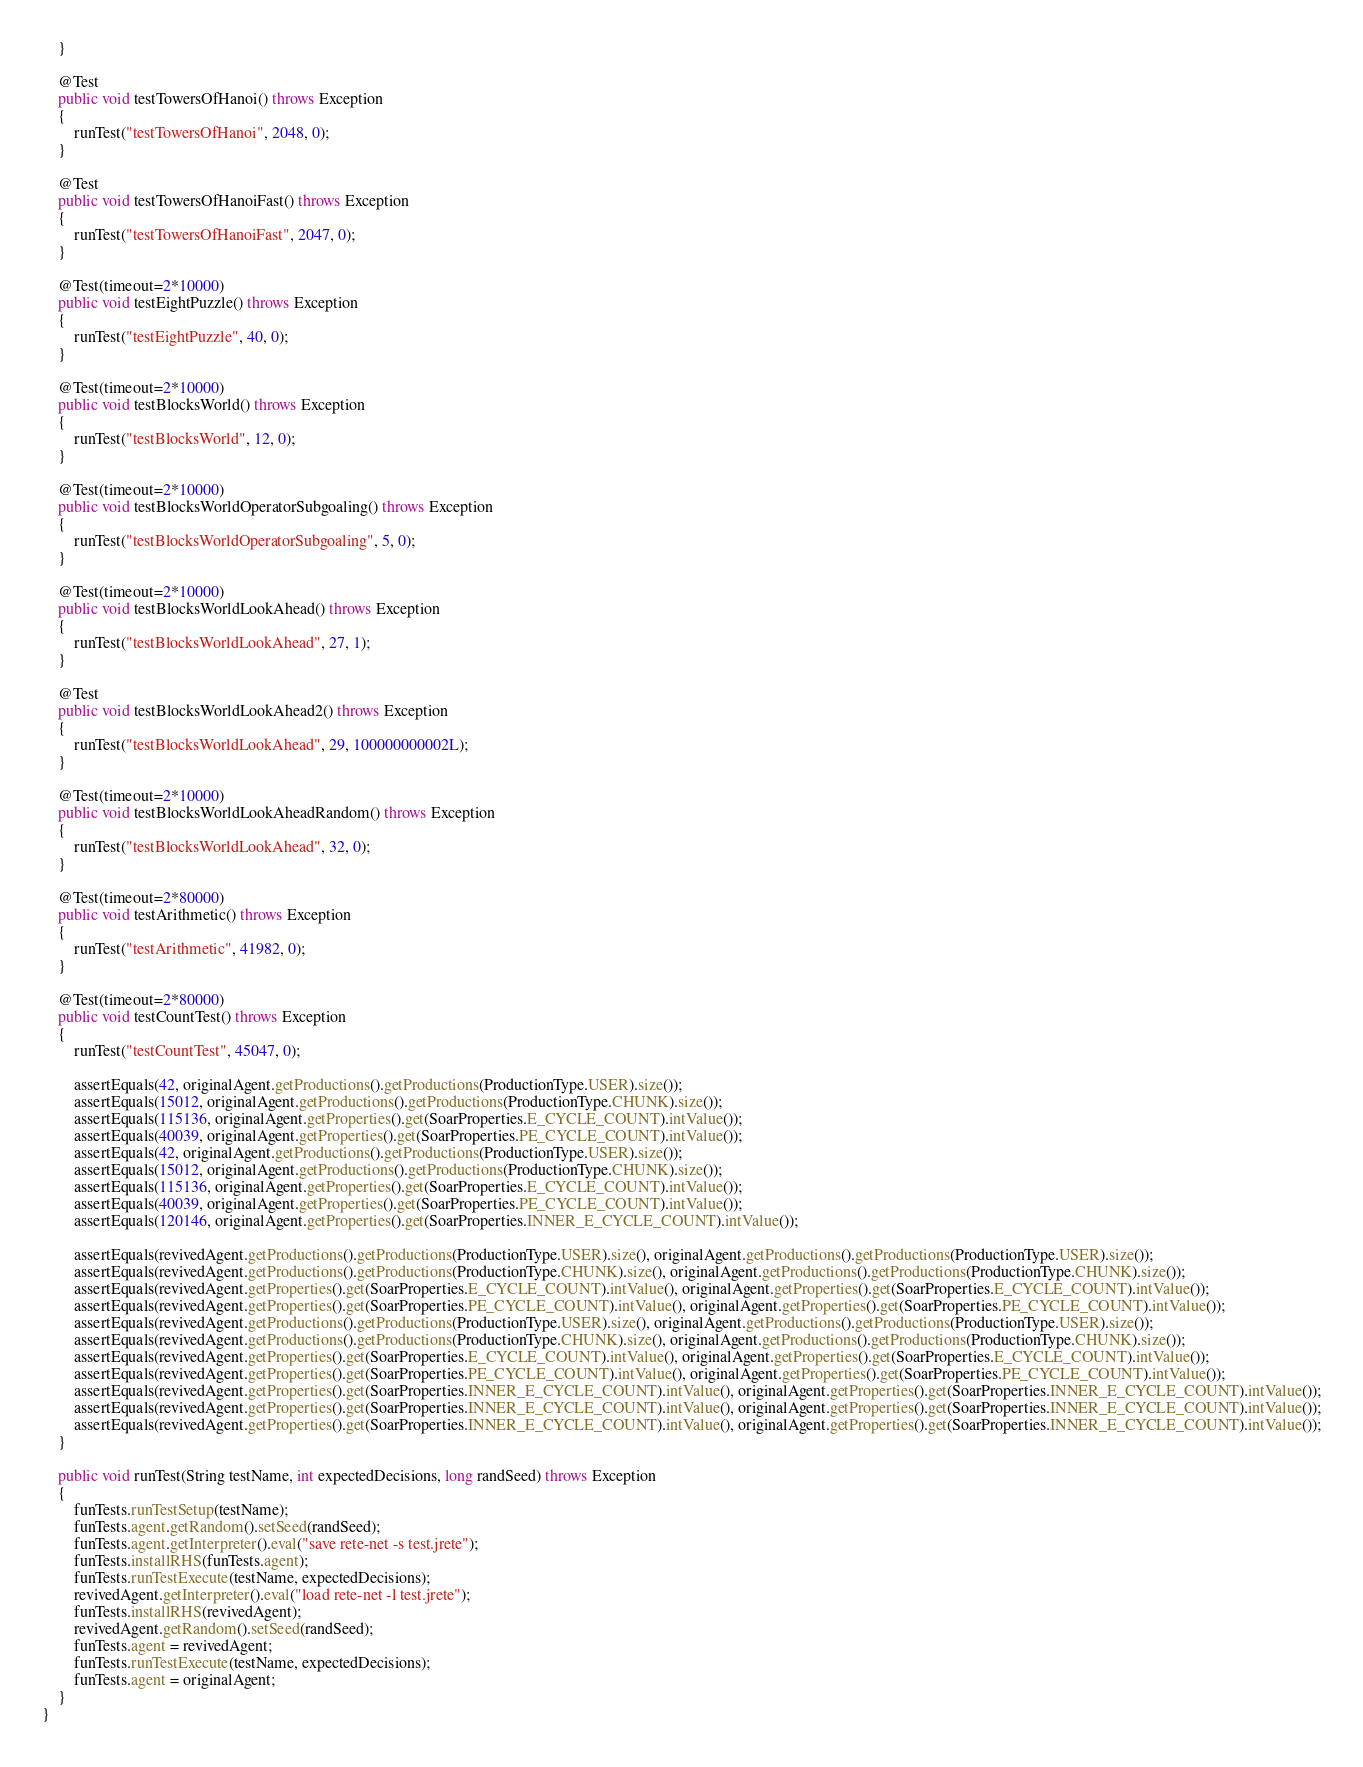<code> <loc_0><loc_0><loc_500><loc_500><_Java_>    }
    
    @Test
    public void testTowersOfHanoi() throws Exception
    {
        runTest("testTowersOfHanoi", 2048, 0);
    }
    
    @Test
    public void testTowersOfHanoiFast() throws Exception
    {
        runTest("testTowersOfHanoiFast", 2047, 0);
    }
    
    @Test(timeout=2*10000)
    public void testEightPuzzle() throws Exception
    {
        runTest("testEightPuzzle", 40, 0);
    }
    
    @Test(timeout=2*10000)
    public void testBlocksWorld() throws Exception
    {
        runTest("testBlocksWorld", 12, 0);
    }
 
    @Test(timeout=2*10000)
    public void testBlocksWorldOperatorSubgoaling() throws Exception
    {
        runTest("testBlocksWorldOperatorSubgoaling", 5, 0);
    }
    
    @Test(timeout=2*10000)
    public void testBlocksWorldLookAhead() throws Exception
    {
        runTest("testBlocksWorldLookAhead", 27, 1);
    }
    
    @Test
    public void testBlocksWorldLookAhead2() throws Exception
    {
        runTest("testBlocksWorldLookAhead", 29, 100000000002L);
    }
    
    @Test(timeout=2*10000)
    public void testBlocksWorldLookAheadRandom() throws Exception
    {
        runTest("testBlocksWorldLookAhead", 32, 0);
    }
    
    @Test(timeout=2*80000)
    public void testArithmetic() throws Exception
    {
        runTest("testArithmetic", 41982, 0);
    } 
    
    @Test(timeout=2*80000)
    public void testCountTest() throws Exception
    {
        runTest("testCountTest", 45047, 0);
        
        assertEquals(42, originalAgent.getProductions().getProductions(ProductionType.USER).size());
        assertEquals(15012, originalAgent.getProductions().getProductions(ProductionType.CHUNK).size());
        assertEquals(115136, originalAgent.getProperties().get(SoarProperties.E_CYCLE_COUNT).intValue());
        assertEquals(40039, originalAgent.getProperties().get(SoarProperties.PE_CYCLE_COUNT).intValue());
        assertEquals(42, originalAgent.getProductions().getProductions(ProductionType.USER).size());
        assertEquals(15012, originalAgent.getProductions().getProductions(ProductionType.CHUNK).size());
        assertEquals(115136, originalAgent.getProperties().get(SoarProperties.E_CYCLE_COUNT).intValue());
        assertEquals(40039, originalAgent.getProperties().get(SoarProperties.PE_CYCLE_COUNT).intValue());
        assertEquals(120146, originalAgent.getProperties().get(SoarProperties.INNER_E_CYCLE_COUNT).intValue());
        
        assertEquals(revivedAgent.getProductions().getProductions(ProductionType.USER).size(), originalAgent.getProductions().getProductions(ProductionType.USER).size());
        assertEquals(revivedAgent.getProductions().getProductions(ProductionType.CHUNK).size(), originalAgent.getProductions().getProductions(ProductionType.CHUNK).size());
        assertEquals(revivedAgent.getProperties().get(SoarProperties.E_CYCLE_COUNT).intValue(), originalAgent.getProperties().get(SoarProperties.E_CYCLE_COUNT).intValue());
        assertEquals(revivedAgent.getProperties().get(SoarProperties.PE_CYCLE_COUNT).intValue(), originalAgent.getProperties().get(SoarProperties.PE_CYCLE_COUNT).intValue());
        assertEquals(revivedAgent.getProductions().getProductions(ProductionType.USER).size(), originalAgent.getProductions().getProductions(ProductionType.USER).size());
        assertEquals(revivedAgent.getProductions().getProductions(ProductionType.CHUNK).size(), originalAgent.getProductions().getProductions(ProductionType.CHUNK).size());
        assertEquals(revivedAgent.getProperties().get(SoarProperties.E_CYCLE_COUNT).intValue(), originalAgent.getProperties().get(SoarProperties.E_CYCLE_COUNT).intValue());
        assertEquals(revivedAgent.getProperties().get(SoarProperties.PE_CYCLE_COUNT).intValue(), originalAgent.getProperties().get(SoarProperties.PE_CYCLE_COUNT).intValue());
        assertEquals(revivedAgent.getProperties().get(SoarProperties.INNER_E_CYCLE_COUNT).intValue(), originalAgent.getProperties().get(SoarProperties.INNER_E_CYCLE_COUNT).intValue());
        assertEquals(revivedAgent.getProperties().get(SoarProperties.INNER_E_CYCLE_COUNT).intValue(), originalAgent.getProperties().get(SoarProperties.INNER_E_CYCLE_COUNT).intValue());
        assertEquals(revivedAgent.getProperties().get(SoarProperties.INNER_E_CYCLE_COUNT).intValue(), originalAgent.getProperties().get(SoarProperties.INNER_E_CYCLE_COUNT).intValue());
    }
    
    public void runTest(String testName, int expectedDecisions, long randSeed) throws Exception
    {
        funTests.runTestSetup(testName);
        funTests.agent.getRandom().setSeed(randSeed);
        funTests.agent.getInterpreter().eval("save rete-net -s test.jrete");
        funTests.installRHS(funTests.agent);
        funTests.runTestExecute(testName, expectedDecisions);
        revivedAgent.getInterpreter().eval("load rete-net -l test.jrete");
        funTests.installRHS(revivedAgent);
        revivedAgent.getRandom().setSeed(randSeed);
        funTests.agent = revivedAgent;
        funTests.runTestExecute(testName, expectedDecisions);
        funTests.agent = originalAgent;
    }
}
</code> 